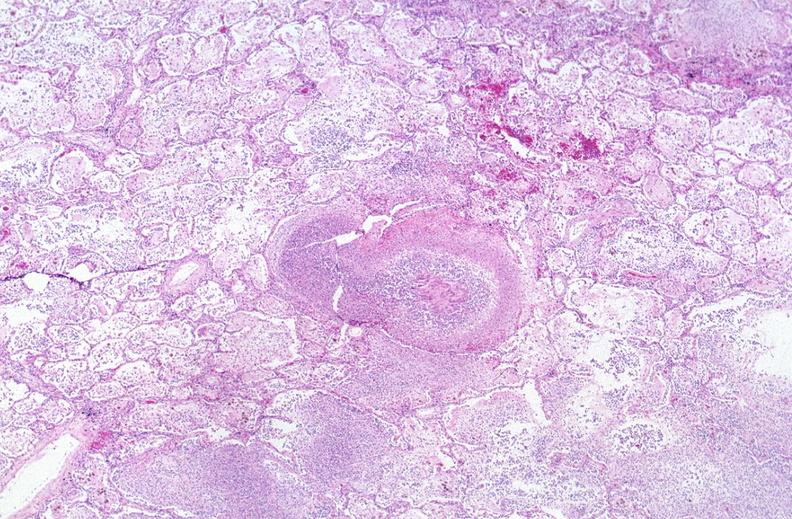where is this?
Answer the question using a single word or phrase. Lung 